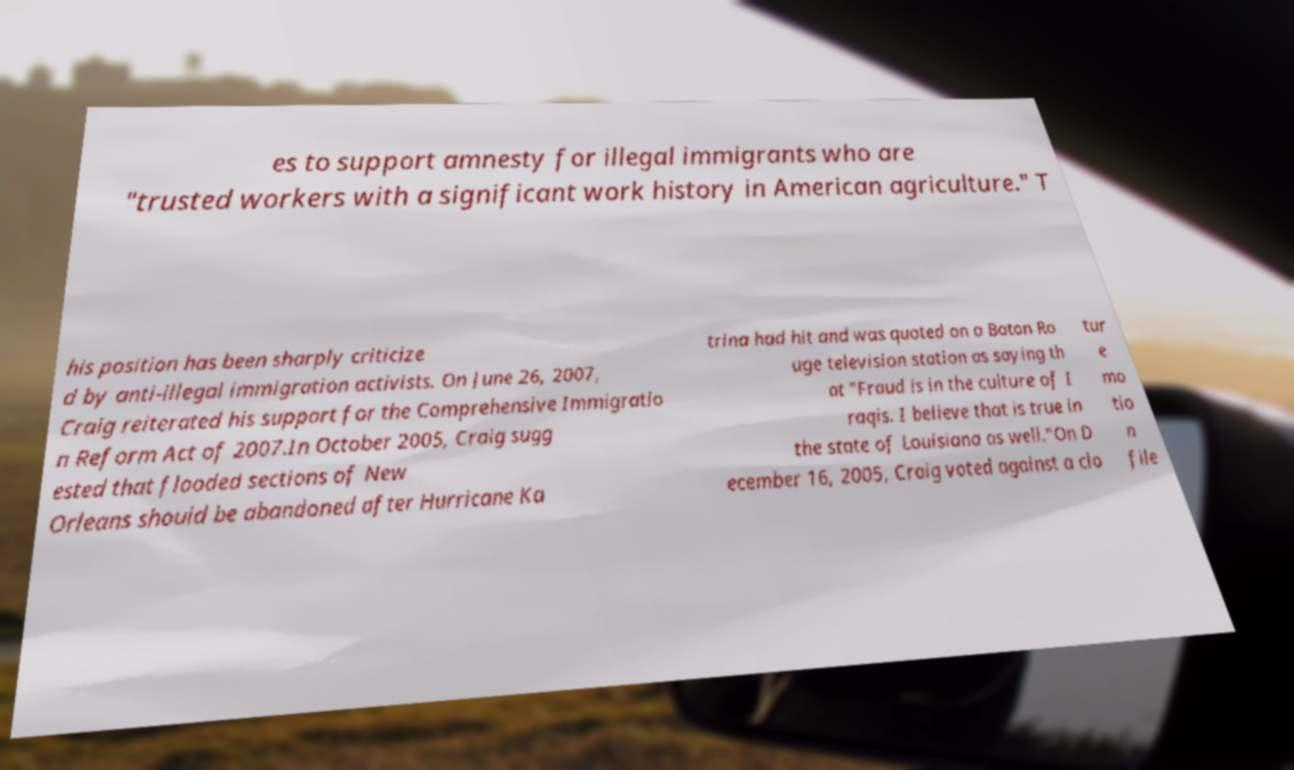Could you assist in decoding the text presented in this image and type it out clearly? es to support amnesty for illegal immigrants who are "trusted workers with a significant work history in American agriculture." T his position has been sharply criticize d by anti-illegal immigration activists. On June 26, 2007, Craig reiterated his support for the Comprehensive Immigratio n Reform Act of 2007.In October 2005, Craig sugg ested that flooded sections of New Orleans should be abandoned after Hurricane Ka trina had hit and was quoted on a Baton Ro uge television station as saying th at "Fraud is in the culture of I raqis. I believe that is true in the state of Louisiana as well."On D ecember 16, 2005, Craig voted against a clo tur e mo tio n file 